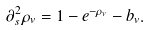Convert formula to latex. <formula><loc_0><loc_0><loc_500><loc_500>\partial ^ { 2 } _ { s } \rho _ { v } = 1 - e ^ { - \rho _ { v } } - b _ { v } .</formula> 